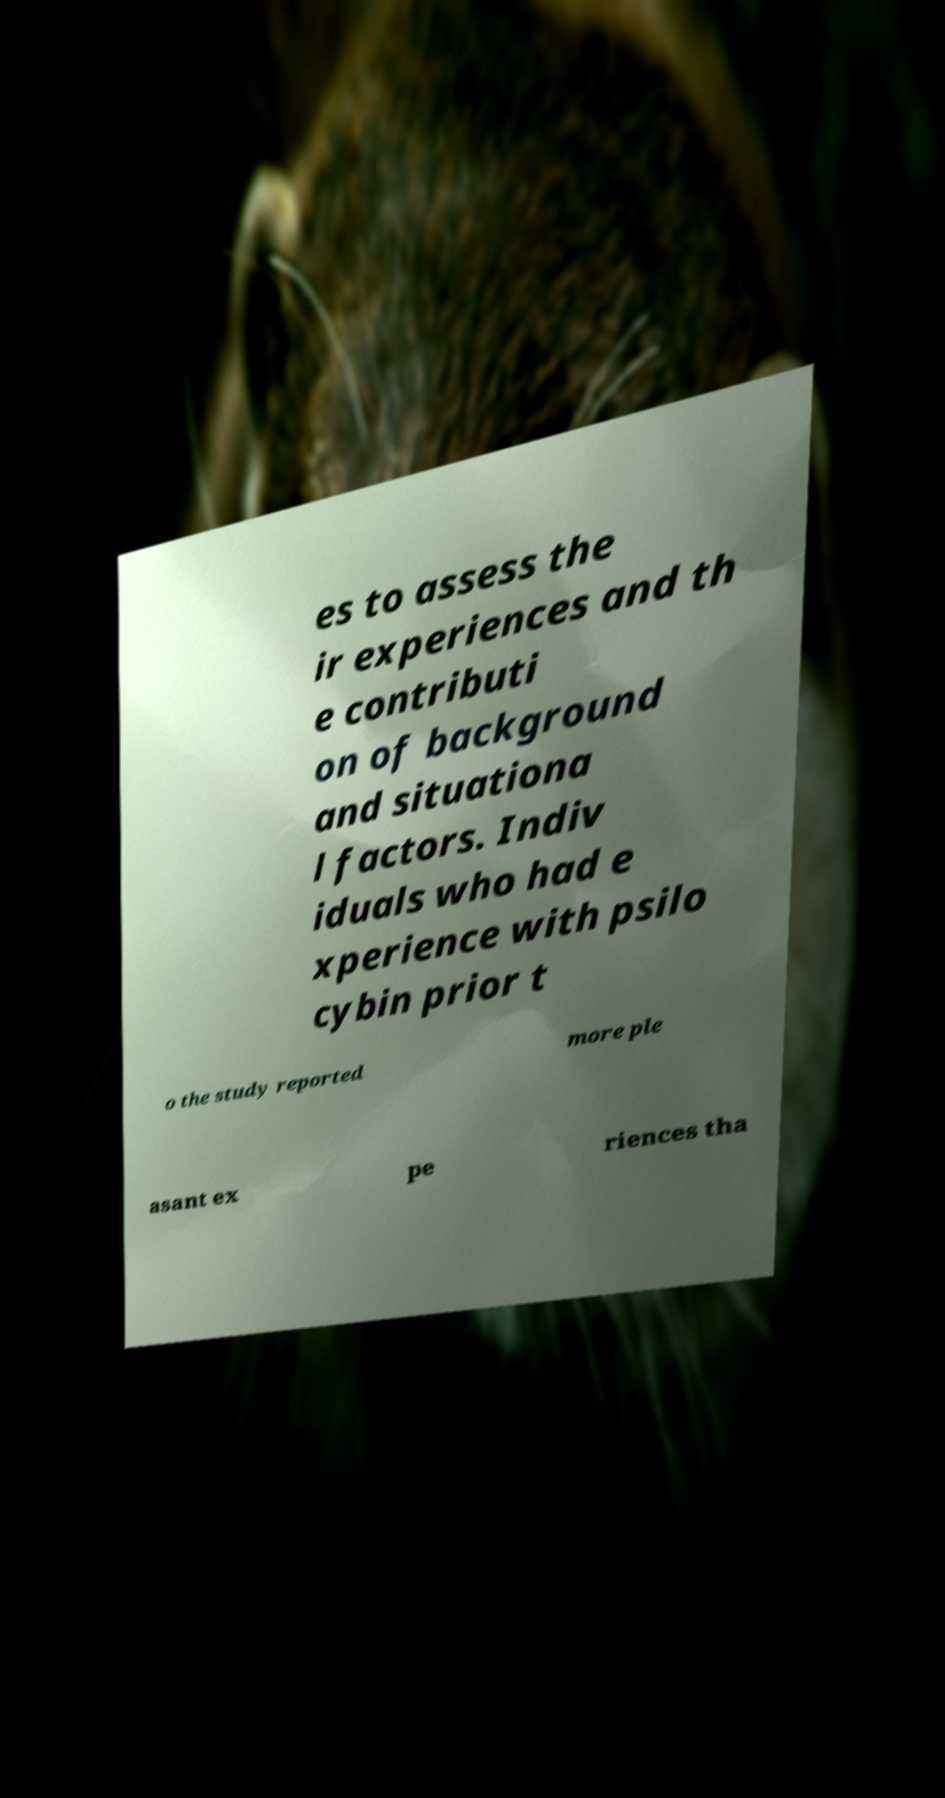Please identify and transcribe the text found in this image. es to assess the ir experiences and th e contributi on of background and situationa l factors. Indiv iduals who had e xperience with psilo cybin prior t o the study reported more ple asant ex pe riences tha 